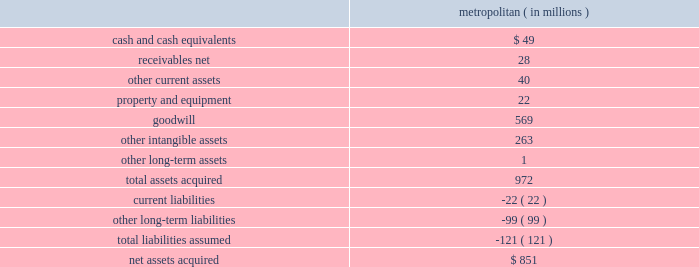Humana inc .
Notes to consolidated financial statements 2014 ( continued ) not be estimated based on observable market prices , and as such , unobservable inputs were used .
For auction rate securities , valuation methodologies include consideration of the quality of the sector and issuer , underlying collateral , underlying final maturity dates , and liquidity .
Recently issued accounting pronouncements there are no recently issued accounting standards that apply to us or that will have a material impact on our results of operations , financial condition , or cash flows .
Acquisitions on december 21 , 2012 , we acquired metropolitan health networks , inc. , or metropolitan , a medical services organization , or mso , that coordinates medical care for medicare advantage beneficiaries and medicaid recipients , primarily in florida .
We paid $ 11.25 per share in cash to acquire all of the outstanding shares of metropolitan and repaid all outstanding debt of metropolitan for a transaction value of $ 851 million , plus transaction expenses .
The preliminary fair values of metropolitan 2019s assets acquired and liabilities assumed at the date of the acquisition are summarized as follows : metropolitan ( in millions ) .
The goodwill was assigned to the health and well-being services segment and is not deductible for tax purposes .
The other intangible assets , which primarily consist of customer contracts and trade names , have a weighted average useful life of 8.4 years .
On october 29 , 2012 , we acquired a noncontrolling equity interest in mcci holdings , llc , or mcci , a privately held mso headquartered in miami , florida that coordinates medical care for medicare advantage and medicaid beneficiaries primarily in florida and texas .
The metropolitan and mcci transactions are expected to provide us with components of a successful integrated care delivery model that has demonstrated scalability to new markets .
A substantial portion of the revenues for both metropolitan and mcci are derived from services provided to humana medicare advantage members under capitation contracts with our health plans .
In addition , metropolitan and mcci provide services to medicare advantage and medicaid members under capitation contracts with third party health plans .
Under these capitation agreements with humana and third party health plans , metropolitan and mcci assume financial risk associated with these medicare advantage and medicaid members. .
What are the total current assets of metropolitan? 
Computations: ((49 + 28) + 40)
Answer: 117.0. 